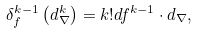Convert formula to latex. <formula><loc_0><loc_0><loc_500><loc_500>\delta _ { f } ^ { k - 1 } \left ( d _ { \nabla } ^ { k } \right ) = k ! d f ^ { k - 1 } \cdot d _ { \nabla } ,</formula> 